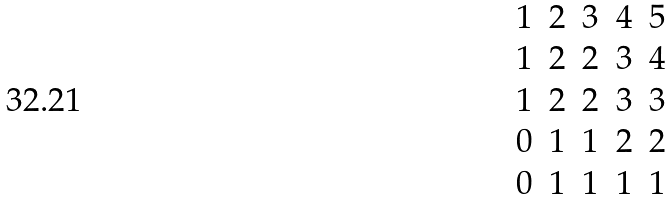<formula> <loc_0><loc_0><loc_500><loc_500>\begin{matrix} 1 & 2 & 3 & 4 & 5 \\ 1 & 2 & 2 & 3 & 4 \\ 1 & 2 & 2 & 3 & 3 \\ 0 & 1 & 1 & 2 & 2 \\ 0 & 1 & 1 & 1 & 1 \end{matrix}</formula> 